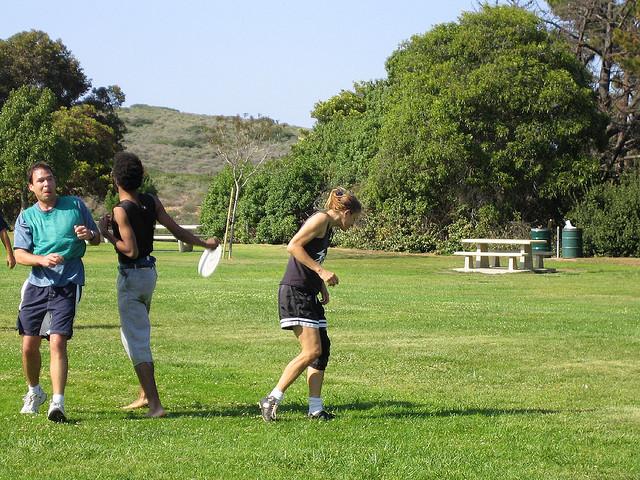What color are the frisbees?
Write a very short answer. White. Are some folks shirtless?
Give a very brief answer. No. How many people are wearing green shirts?
Write a very short answer. 1. Are the garbage cans close to the people or far away?
Be succinct. Far away. Are there mountains in the background?
Write a very short answer. Yes. Which person may be barefoot?
Short answer required. Middle. What color is the girl's shirt?
Give a very brief answer. Black. Are the men wearing shirts?
Quick response, please. Yes. 